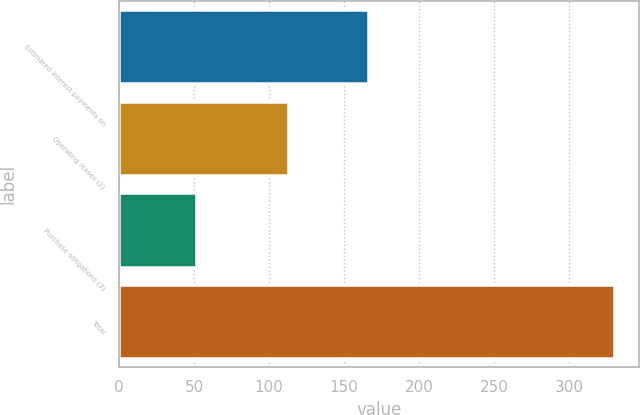Convert chart to OTSL. <chart><loc_0><loc_0><loc_500><loc_500><bar_chart><fcel>Estimated interest payments on<fcel>Operating leases (2)<fcel>Purchase obligations (3)<fcel>Total<nl><fcel>166<fcel>112.6<fcel>51.4<fcel>330<nl></chart> 